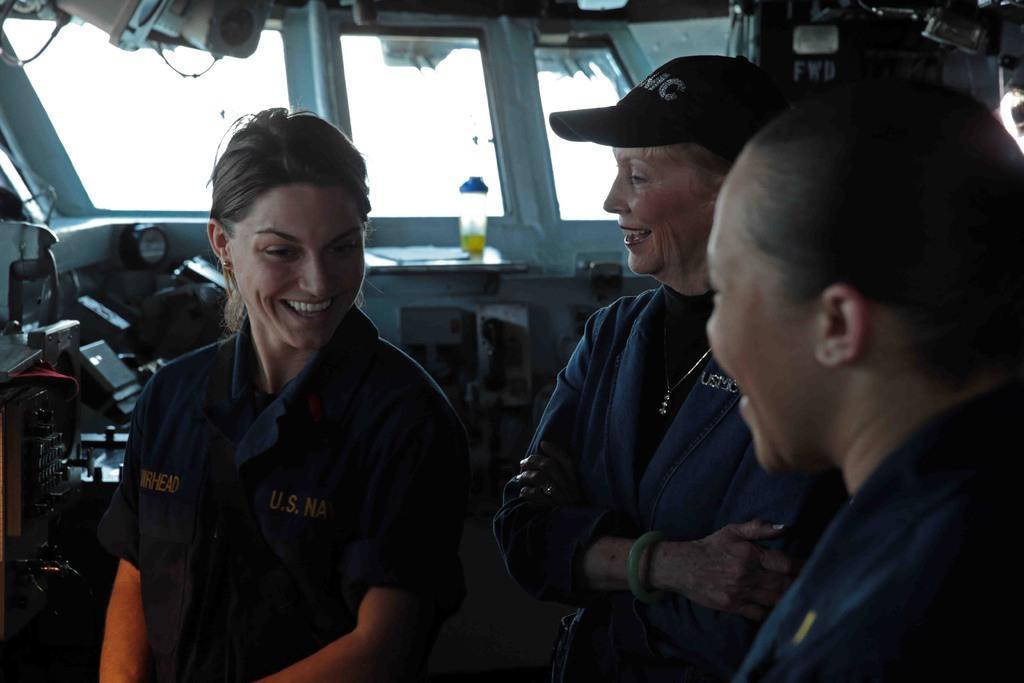In one or two sentences, can you explain what this image depicts? In the image there are three ladies standing and they are smiling. There is a lady with a cap on her head. Behind her there are few machines, glass windows and some other things in the background. 